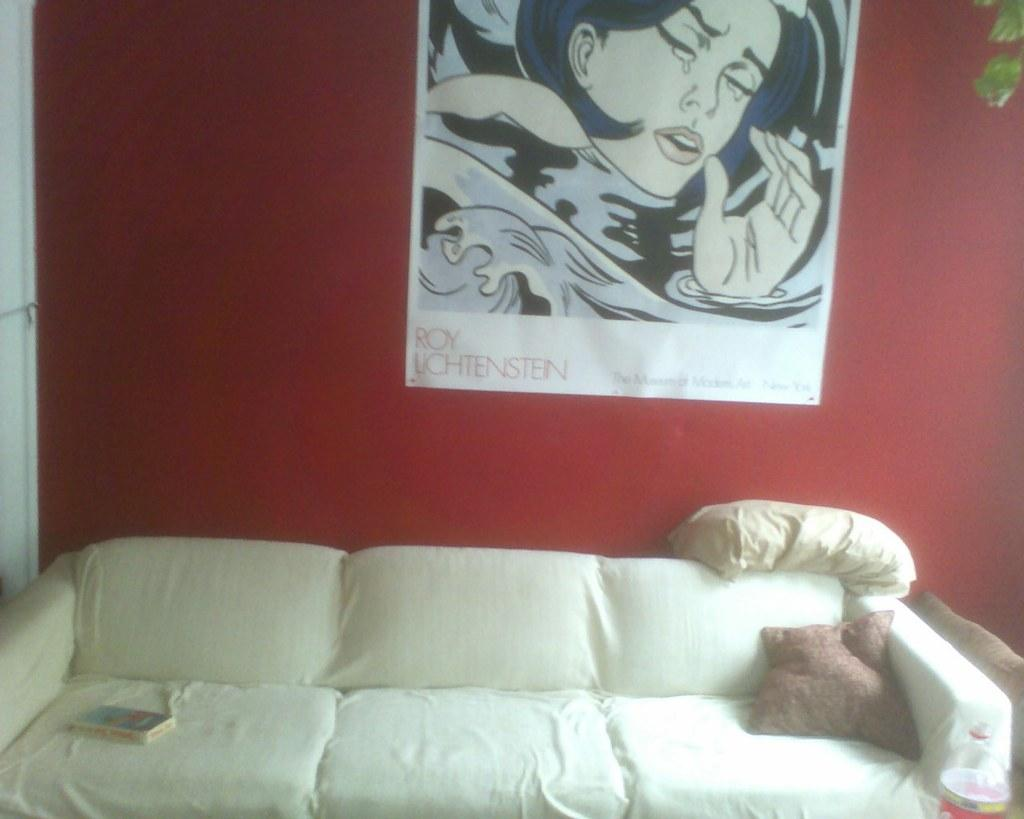What type of furniture is present in the room? There is a sofa in the room. What is placed on the sofa? There is a book and a pillow on the sofa. What can be seen on the wall in the room? There is a poster on the wall. What type of flowers are growing on the range in the image? There are no flowers or range present in the image; it only features a sofa, a book, a pillow, and a poster on the wall. 